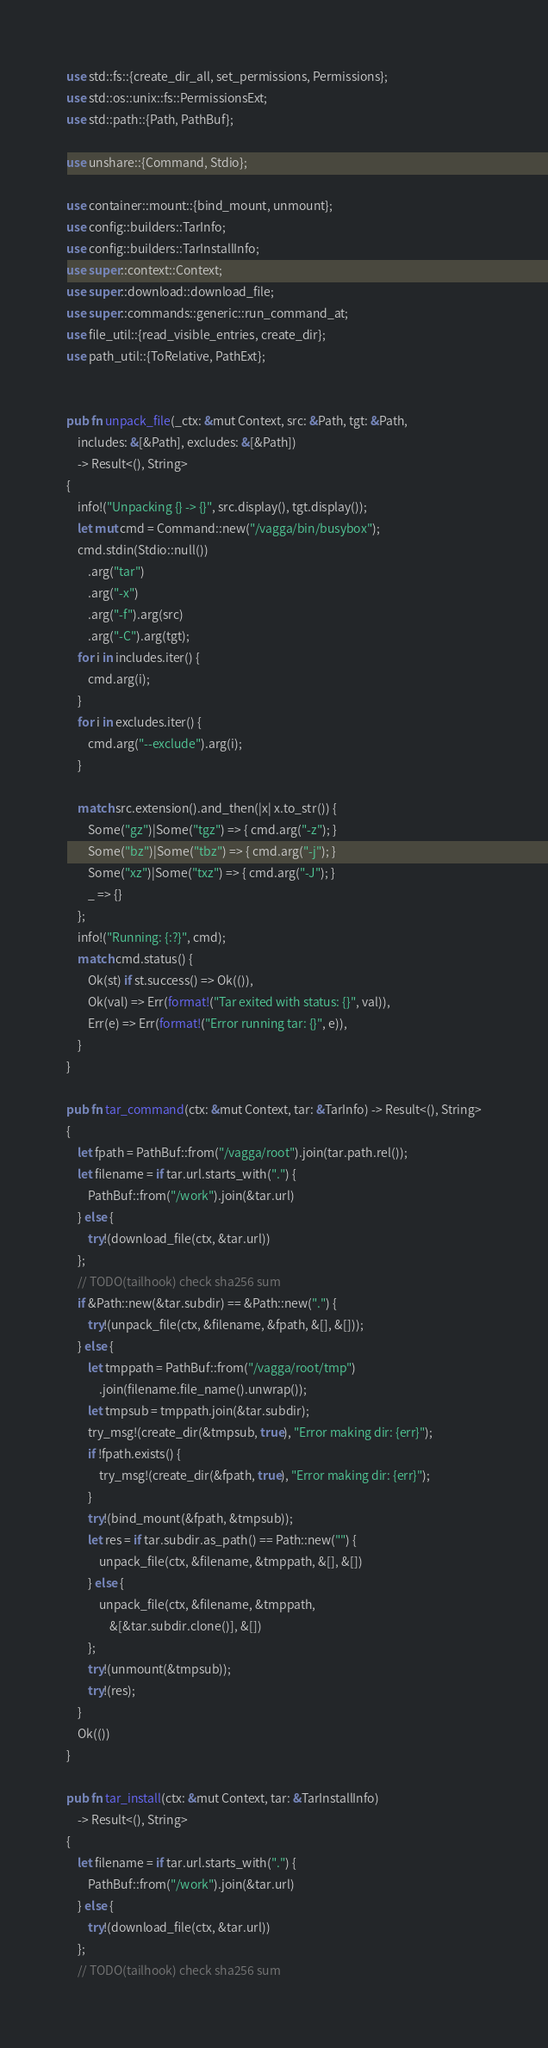Convert code to text. <code><loc_0><loc_0><loc_500><loc_500><_Rust_>use std::fs::{create_dir_all, set_permissions, Permissions};
use std::os::unix::fs::PermissionsExt;
use std::path::{Path, PathBuf};

use unshare::{Command, Stdio};

use container::mount::{bind_mount, unmount};
use config::builders::TarInfo;
use config::builders::TarInstallInfo;
use super::context::Context;
use super::download::download_file;
use super::commands::generic::run_command_at;
use file_util::{read_visible_entries, create_dir};
use path_util::{ToRelative, PathExt};


pub fn unpack_file(_ctx: &mut Context, src: &Path, tgt: &Path,
    includes: &[&Path], excludes: &[&Path])
    -> Result<(), String>
{
    info!("Unpacking {} -> {}", src.display(), tgt.display());
    let mut cmd = Command::new("/vagga/bin/busybox");
    cmd.stdin(Stdio::null())
        .arg("tar")
        .arg("-x")
        .arg("-f").arg(src)
        .arg("-C").arg(tgt);
    for i in includes.iter() {
        cmd.arg(i);
    }
    for i in excludes.iter() {
        cmd.arg("--exclude").arg(i);
    }

    match src.extension().and_then(|x| x.to_str()) {
        Some("gz")|Some("tgz") => { cmd.arg("-z"); }
        Some("bz")|Some("tbz") => { cmd.arg("-j"); }
        Some("xz")|Some("txz") => { cmd.arg("-J"); }
        _ => {}
    };
    info!("Running: {:?}", cmd);
    match cmd.status() {
        Ok(st) if st.success() => Ok(()),
        Ok(val) => Err(format!("Tar exited with status: {}", val)),
        Err(e) => Err(format!("Error running tar: {}", e)),
    }
}

pub fn tar_command(ctx: &mut Context, tar: &TarInfo) -> Result<(), String>
{
    let fpath = PathBuf::from("/vagga/root").join(tar.path.rel());
    let filename = if tar.url.starts_with(".") {
        PathBuf::from("/work").join(&tar.url)
    } else {
        try!(download_file(ctx, &tar.url))
    };
    // TODO(tailhook) check sha256 sum
    if &Path::new(&tar.subdir) == &Path::new(".") {
        try!(unpack_file(ctx, &filename, &fpath, &[], &[]));
    } else {
        let tmppath = PathBuf::from("/vagga/root/tmp")
            .join(filename.file_name().unwrap());
        let tmpsub = tmppath.join(&tar.subdir);
        try_msg!(create_dir(&tmpsub, true), "Error making dir: {err}");
        if !fpath.exists() {
            try_msg!(create_dir(&fpath, true), "Error making dir: {err}");
        }
        try!(bind_mount(&fpath, &tmpsub));
        let res = if tar.subdir.as_path() == Path::new("") {
            unpack_file(ctx, &filename, &tmppath, &[], &[])
        } else {
            unpack_file(ctx, &filename, &tmppath,
                &[&tar.subdir.clone()], &[])
        };
        try!(unmount(&tmpsub));
        try!(res);
    }
    Ok(())
}

pub fn tar_install(ctx: &mut Context, tar: &TarInstallInfo)
    -> Result<(), String>
{
    let filename = if tar.url.starts_with(".") {
        PathBuf::from("/work").join(&tar.url)
    } else {
        try!(download_file(ctx, &tar.url))
    };
    // TODO(tailhook) check sha256 sum</code> 